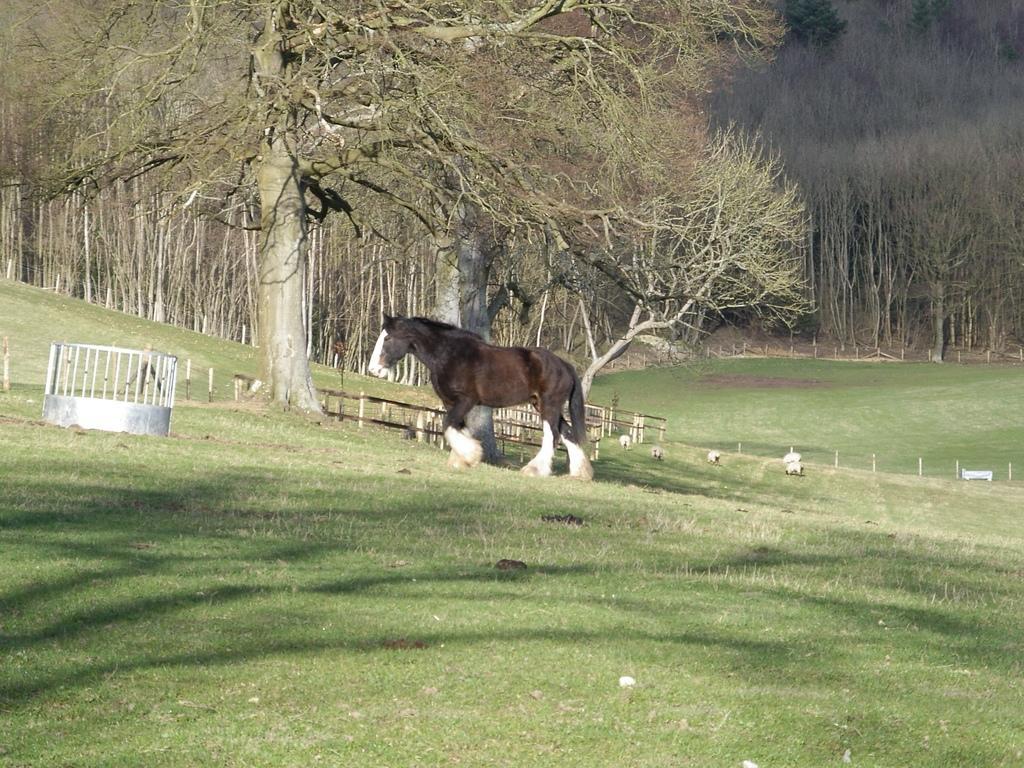Can you describe this image briefly? In this image, we can see some trees. There is a horse in the middle of the image. There is a grass on the ground. 